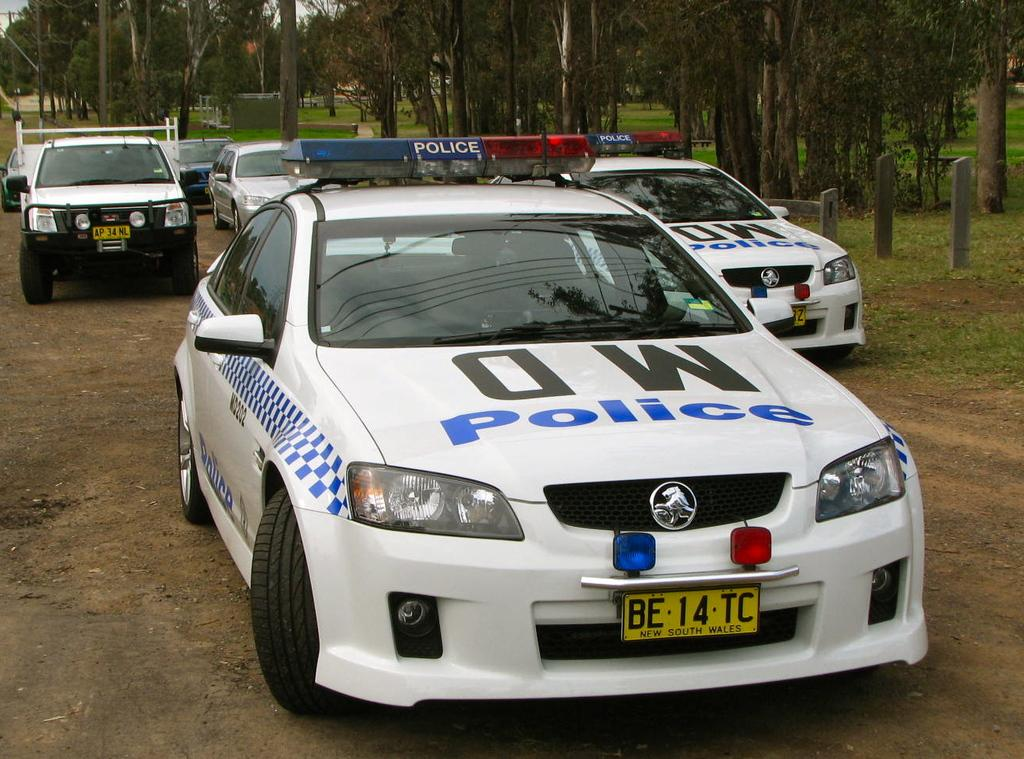What is the main subject of the image? The main subject of the image is many cars. What else can be seen in the image besides cars? There are many trees, plants, and a grassy land in the image. Are there any specific details on the cars? Yes, there is text on some of the cars. What type of jewel can be seen sparkling on the grass in the image? There is no jewel present in the image, and the grass is not sparkling. 